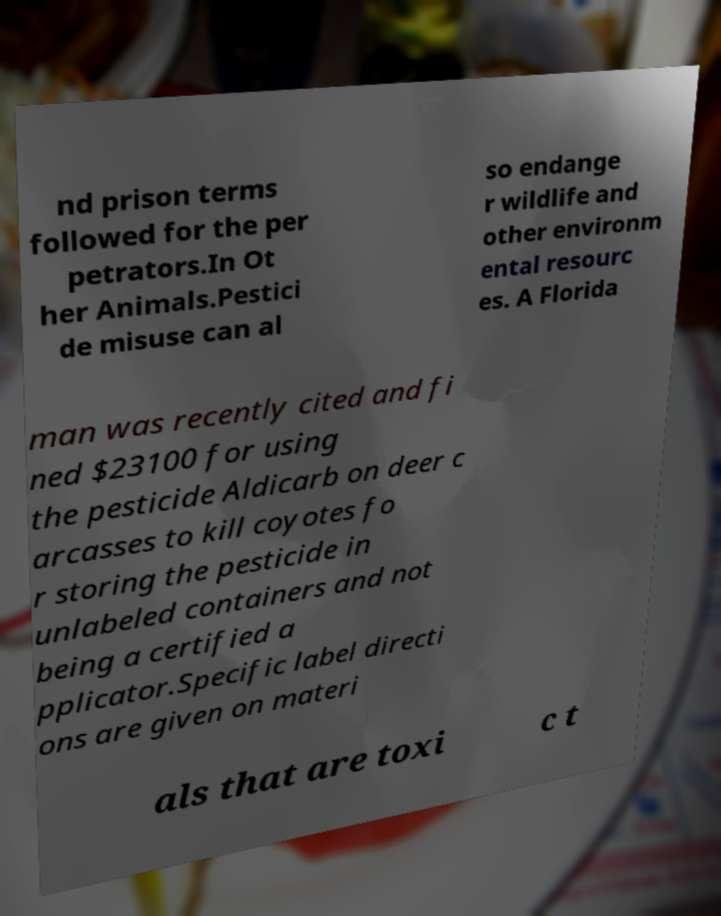What messages or text are displayed in this image? I need them in a readable, typed format. nd prison terms followed for the per petrators.In Ot her Animals.Pestici de misuse can al so endange r wildlife and other environm ental resourc es. A Florida man was recently cited and fi ned $23100 for using the pesticide Aldicarb on deer c arcasses to kill coyotes fo r storing the pesticide in unlabeled containers and not being a certified a pplicator.Specific label directi ons are given on materi als that are toxi c t 